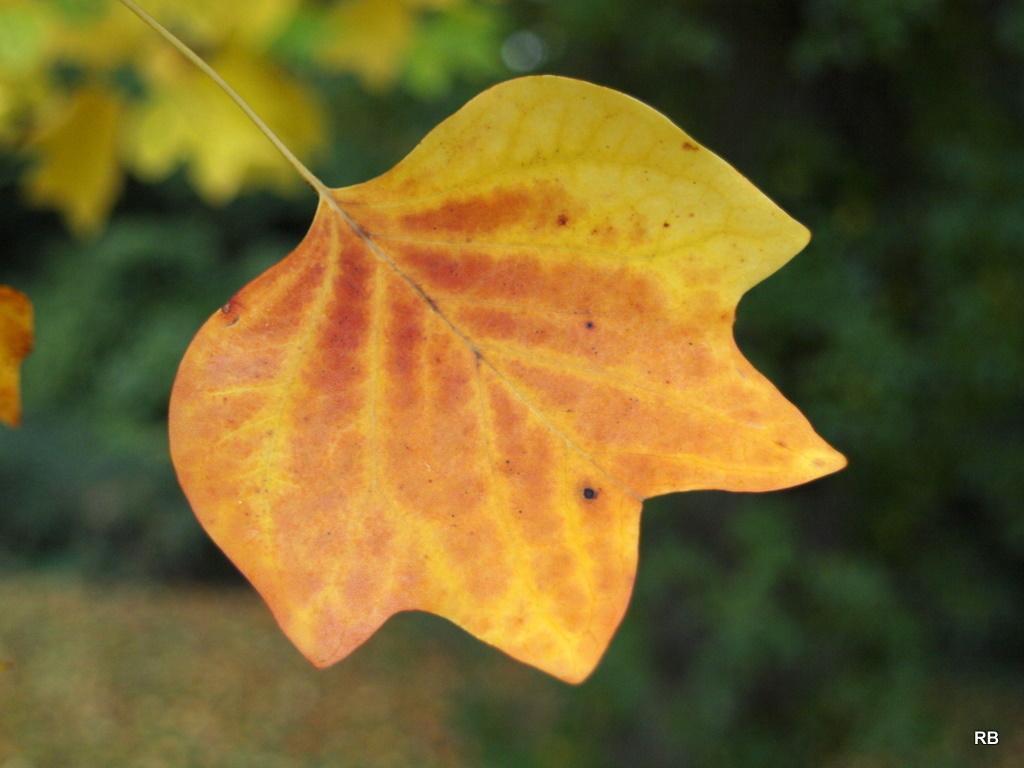Could you give a brief overview of what you see in this image? In the center of the image we can see a leaf. In the background there are plants. 